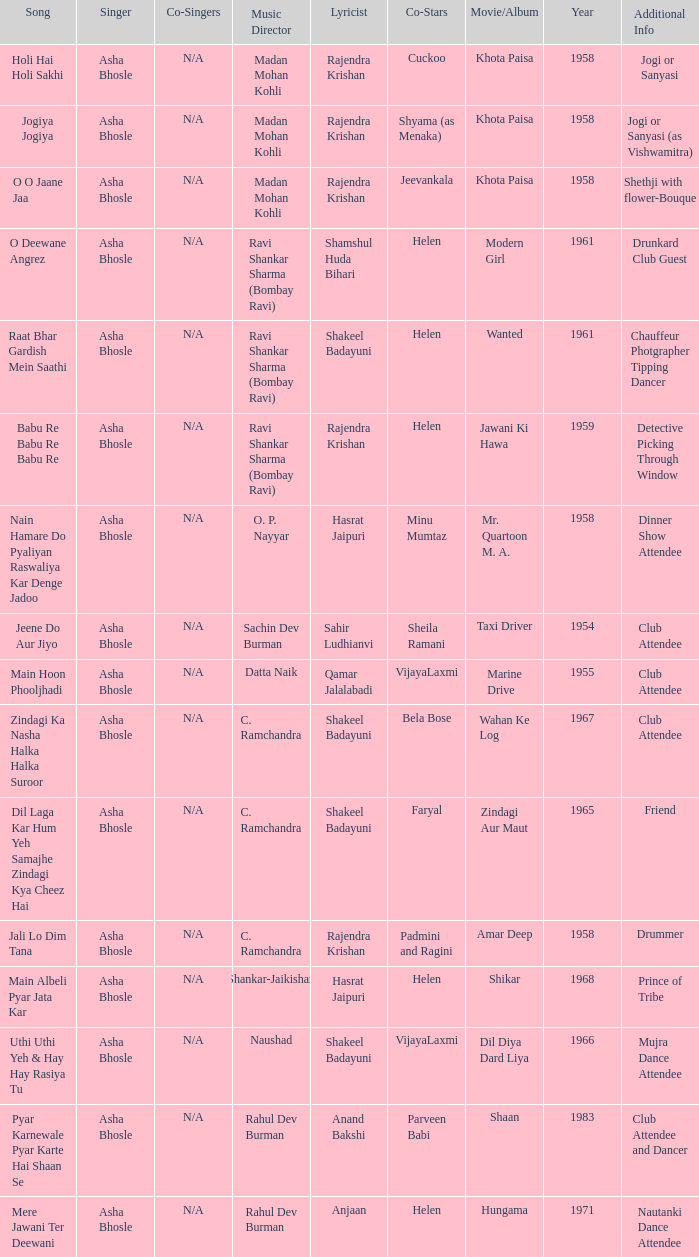How many co-singers were there when Parveen Babi co-starred? 1.0. 